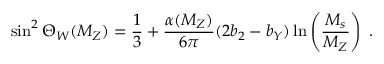<formula> <loc_0><loc_0><loc_500><loc_500>\sin ^ { 2 } \Theta _ { W } ( M _ { Z } ) = \frac { 1 } { 3 } + \frac { \alpha ( M _ { Z } ) } { 6 \pi } ( 2 b _ { 2 } - b _ { Y } ) \ln \left ( \frac { M _ { s } } { M _ { Z } } \right ) \, .</formula> 